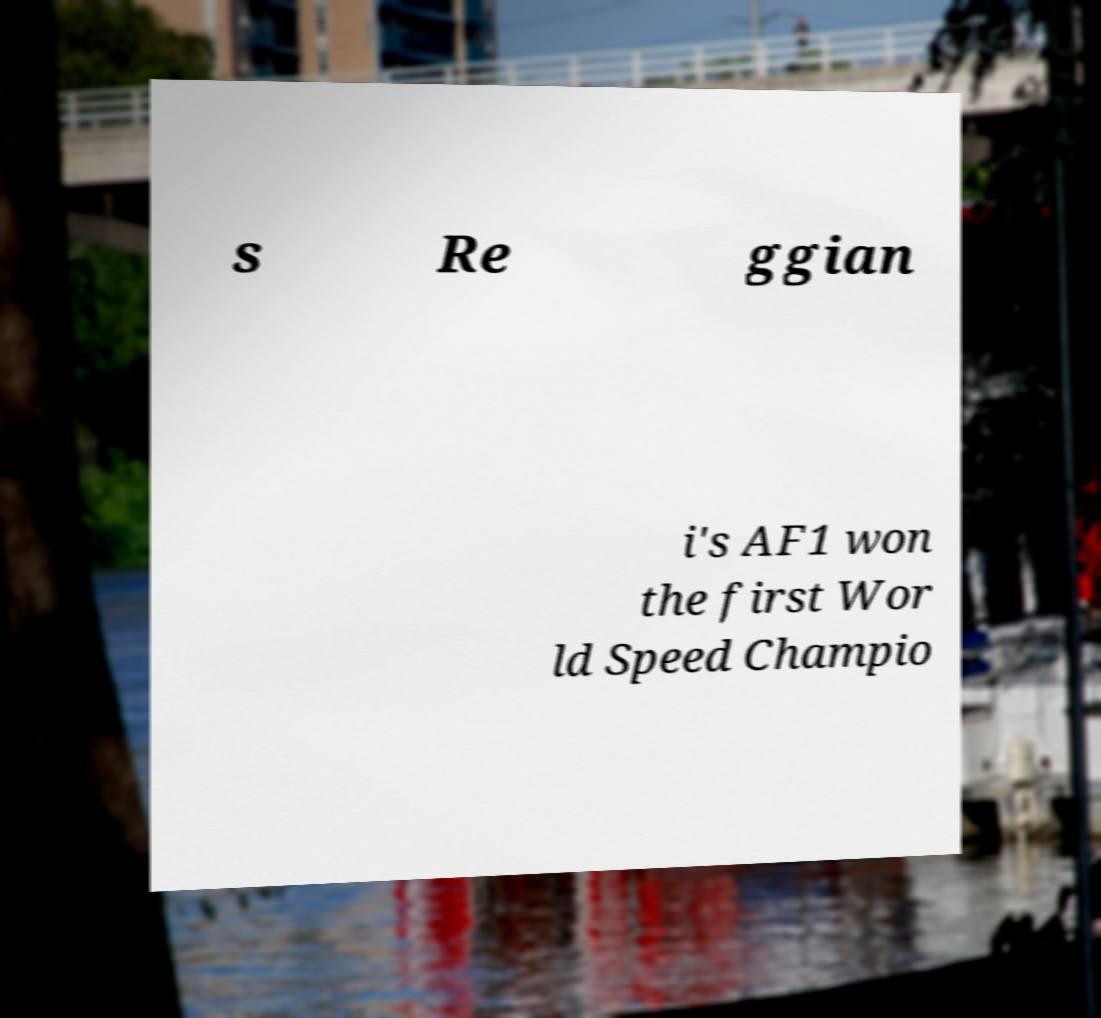For documentation purposes, I need the text within this image transcribed. Could you provide that? s Re ggian i's AF1 won the first Wor ld Speed Champio 